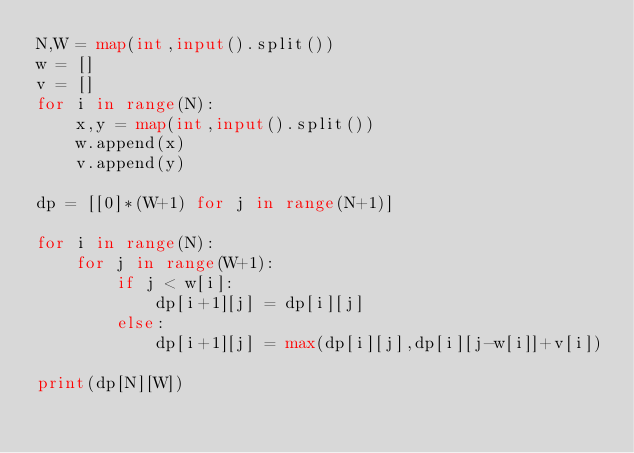<code> <loc_0><loc_0><loc_500><loc_500><_Python_>N,W = map(int,input().split())
w = []
v = []
for i in range(N):
    x,y = map(int,input().split())
    w.append(x)
    v.append(y)

dp = [[0]*(W+1) for j in range(N+1)]

for i in range(N):
    for j in range(W+1):
        if j < w[i]:
            dp[i+1][j] = dp[i][j]
        else:
            dp[i+1][j] = max(dp[i][j],dp[i][j-w[i]]+v[i])

print(dp[N][W])</code> 